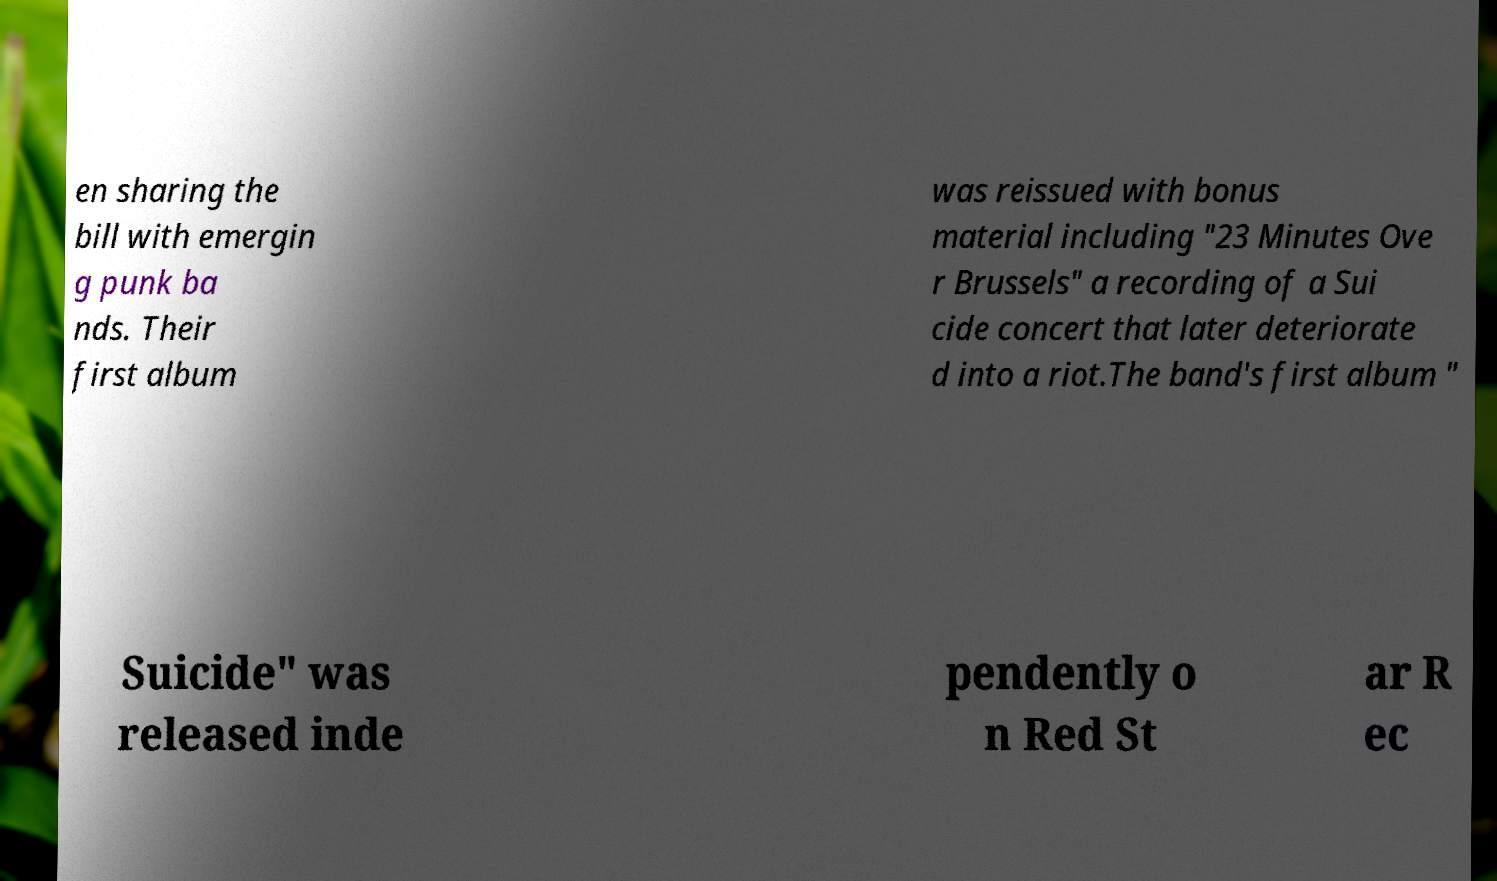There's text embedded in this image that I need extracted. Can you transcribe it verbatim? en sharing the bill with emergin g punk ba nds. Their first album was reissued with bonus material including "23 Minutes Ove r Brussels" a recording of a Sui cide concert that later deteriorate d into a riot.The band's first album " Suicide" was released inde pendently o n Red St ar R ec 